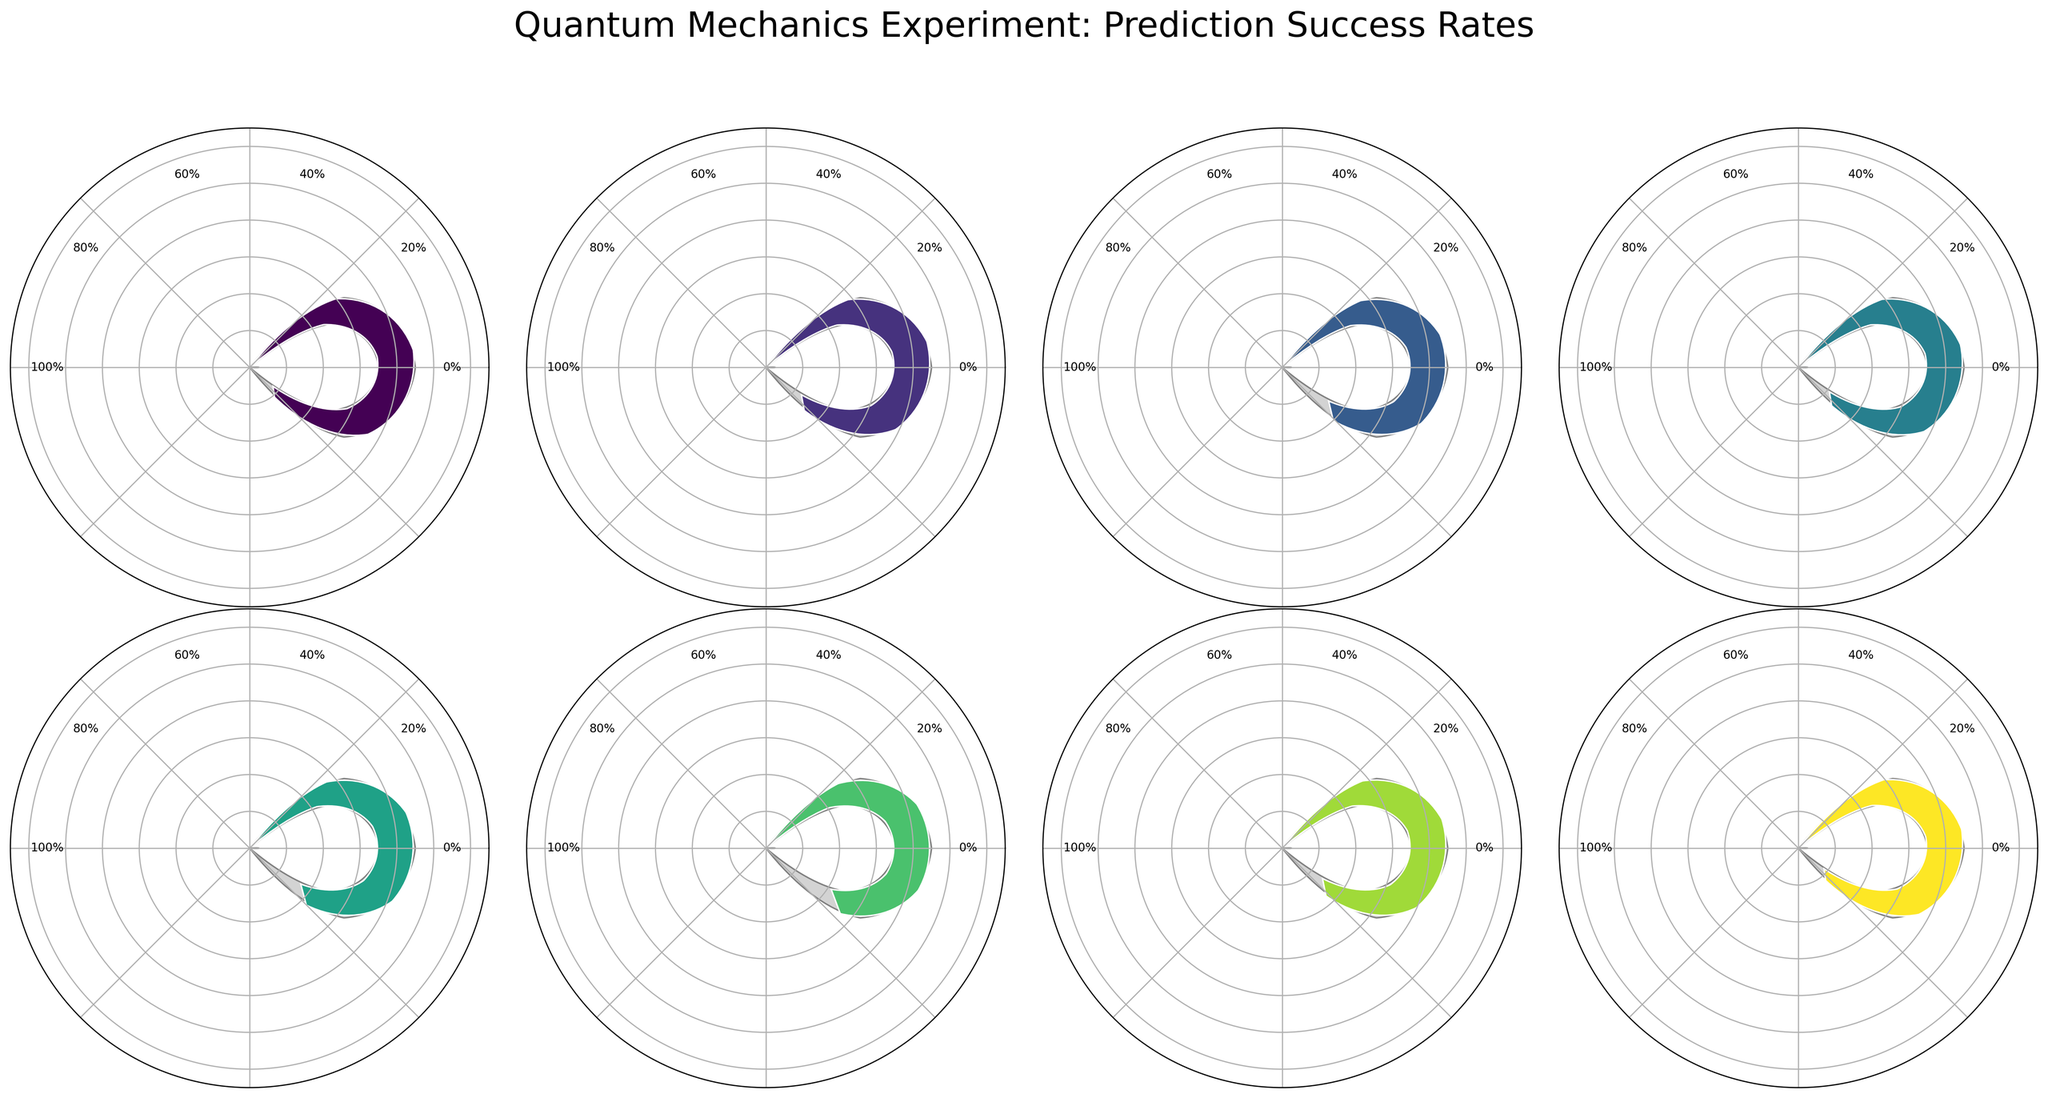What is the title of the figure? The title is displayed at the top of the figure. It reads "Quantum Mechanics Experiment: Prediction Success Rates" with a large, clear font.
Answer: Quantum Mechanics Experiment: Prediction Success Rates Which particle has the highest success rate? By examining the different gauge charts, the Electron has the highest success rate of 92.5%, displayed prominently in the Electron's section.
Answer: Electron How does the success rate of the Neutron compare to that of the Proton? The success rate for the Neutron is 85.3%, and for the Proton, it is 90.1%. Comparing these values shows that the Proton's success rate is higher.
Answer: Proton's rate is higher What is the range of the success rates presented in the figure? The success rates range from the lowest, which is for Neutrino at 79.6%, to the highest, which is for Electron at 92.5%. The range is calculated as 92.5% - 79.6% = 12.9%.
Answer: 12.9% How much higher is the success rate of Photons compared to Neutrinos? The success rate for Photon is 88.7%, and for Neutrino, it is 79.6%. The difference is found by subtracting the Neutrino’s rate from the Photon’s rate: 88.7% - 79.6% = 9.1%.
Answer: 9.1% What is the average success rate across all particles? Summing the success rates of all particles (92.5 + 88.7 + 85.3 + 90.1 + 83.9 + 79.6 + 87.2 + 91.8) and dividing by the number of particles (8) gives the average: (699.1 / 8) = 87.39%.
Answer: 87.39% Which two particles have the most similar success rates? Looking at the values, the success rates for Positron (87.2%) and Photon (88.7%) are the closest together, with a difference of 1.5%.
Answer: Positron and Photon If we categorize particles with a success rate above 90% as high success rate particles, how many particles fall into this category? Particles with a success rate above 90% are Electron (92.5%), Proton (90.1%), and Alpha Particle (91.8%). There are three such particles.
Answer: 3 Identify any particle types with success rates below 80%. By examining the success rates, only Neutrino has a success rate below 80%, which is 79.6%.
Answer: Neutrino What is the median success rate of the particles? Listing the success rates in order (79.6%, 83.9%, 85.3%, 87.2%, 88.7%, 90.1%, 91.8%, 92.5%) and finding the middle two values (87.2% and 88.7%), the median is (87.2 + 88.7) / 2 = 87.95%.
Answer: 87.95% 